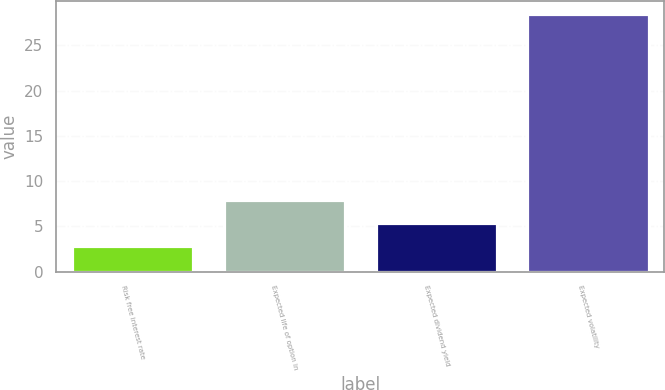Convert chart. <chart><loc_0><loc_0><loc_500><loc_500><bar_chart><fcel>Risk free interest rate<fcel>Expected life of option in<fcel>Expected dividend yield<fcel>Expected volatility<nl><fcel>2.8<fcel>7.94<fcel>5.37<fcel>28.5<nl></chart> 